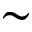Convert formula to latex. <formula><loc_0><loc_0><loc_500><loc_500>\sim</formula> 